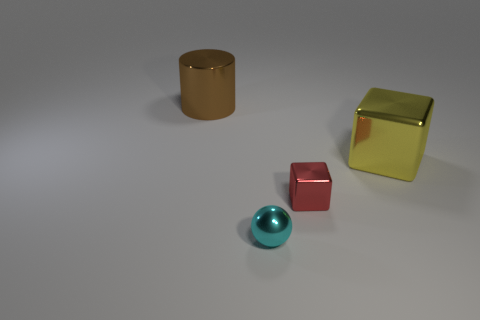Add 2 red things. How many objects exist? 6 Subtract all cylinders. How many objects are left? 3 Add 2 yellow metal objects. How many yellow metal objects exist? 3 Subtract 0 blue cylinders. How many objects are left? 4 Subtract all small yellow cubes. Subtract all brown metal objects. How many objects are left? 3 Add 1 big yellow metallic blocks. How many big yellow metallic blocks are left? 2 